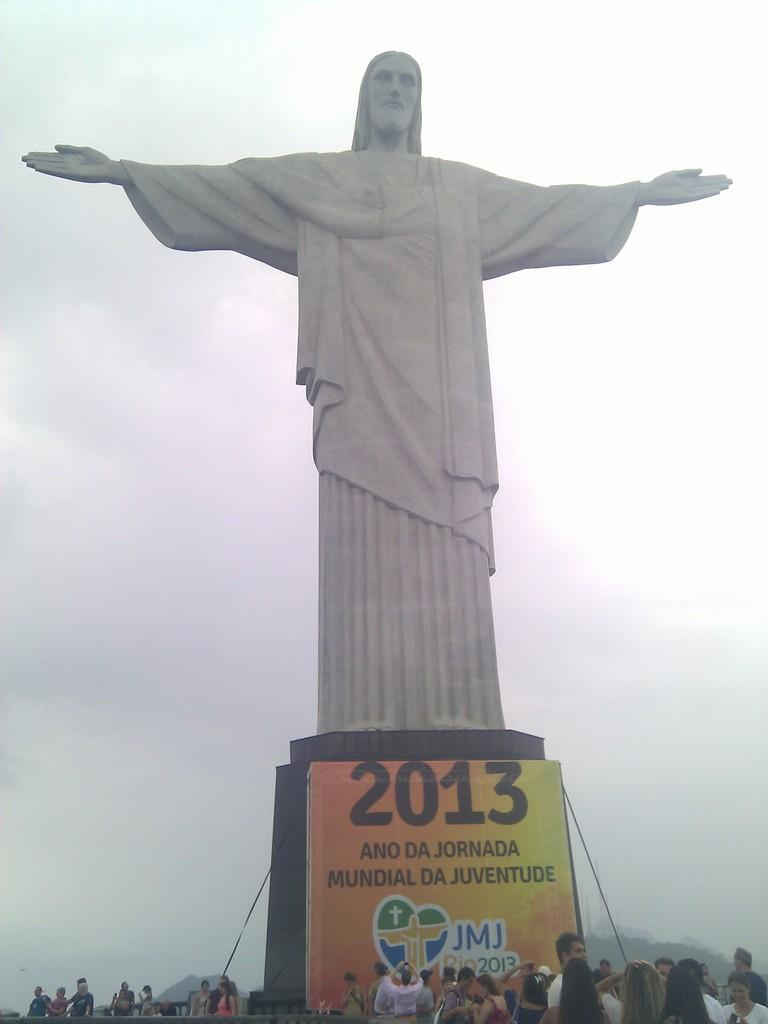<image>
Share a concise interpretation of the image provided. a statue with the year 2013 under it 